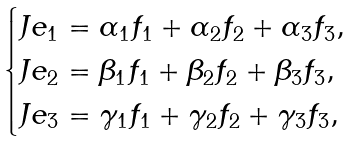Convert formula to latex. <formula><loc_0><loc_0><loc_500><loc_500>\begin{cases} J e _ { 1 } = \alpha _ { 1 } f _ { 1 } + \alpha _ { 2 } f _ { 2 } + \alpha _ { 3 } f _ { 3 } , \\ J e _ { 2 } = \beta _ { 1 } f _ { 1 } + \beta _ { 2 } f _ { 2 } + \beta _ { 3 } f _ { 3 } , \\ J e _ { 3 } = \gamma _ { 1 } f _ { 1 } + \gamma _ { 2 } f _ { 2 } + \gamma _ { 3 } f _ { 3 } , \end{cases}</formula> 